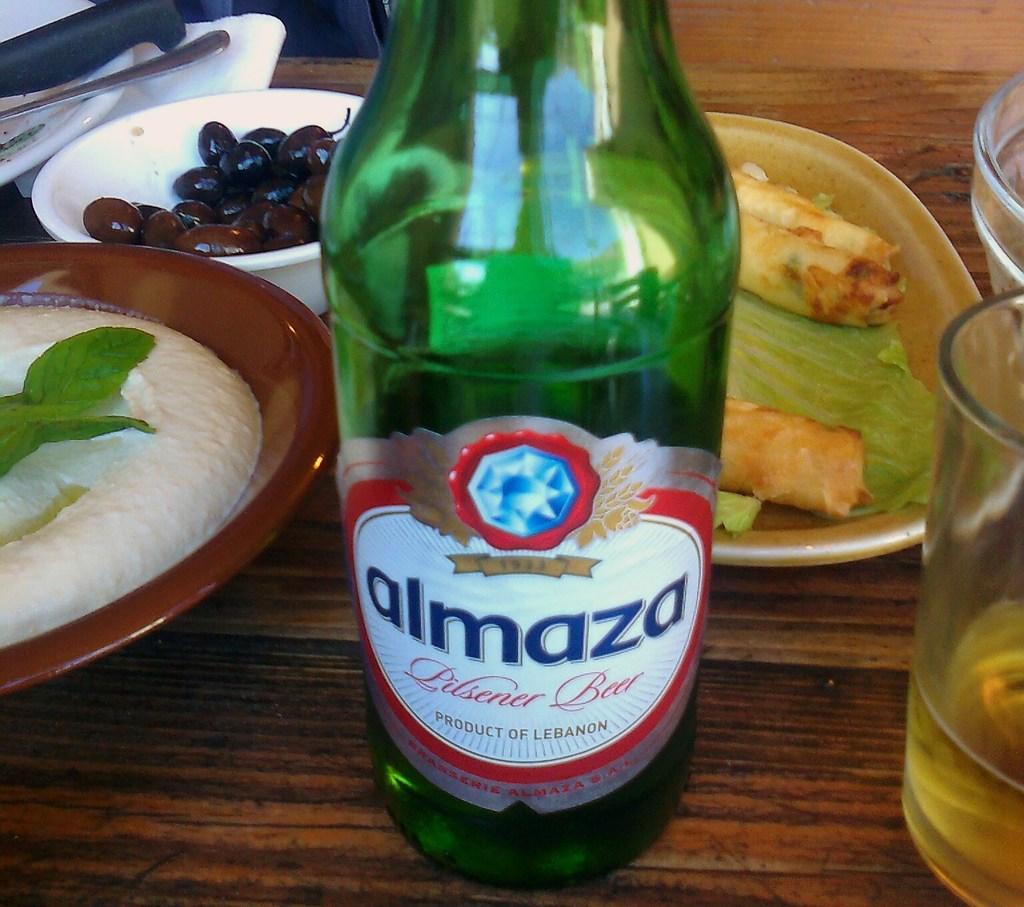What type of beer is almaza?
Your response must be concise. Pilsner. 